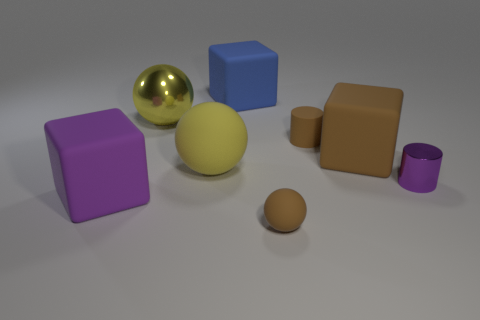Add 1 brown shiny cylinders. How many objects exist? 9 Subtract all cylinders. How many objects are left? 6 Add 5 small brown cylinders. How many small brown cylinders exist? 6 Subtract 1 blue blocks. How many objects are left? 7 Subtract all purple matte blocks. Subtract all big purple matte cubes. How many objects are left? 6 Add 1 large yellow matte spheres. How many large yellow matte spheres are left? 2 